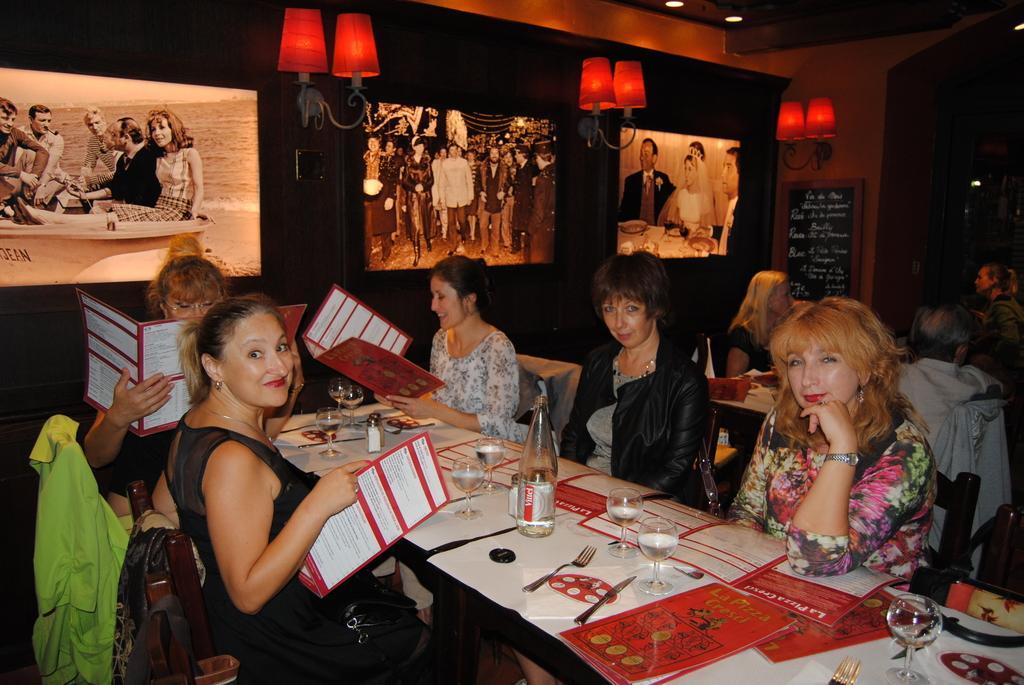Describe this image in one or two sentences. In this picture I can see 5 women sitting on chairs in front and I can see tables in front of them, on which there are glasses, a bottle, few papers and other things. I can also see that 3 women are holding cards in their hands. In the background I can see the wall on which there are 3 photos and I can see the lights. On the right side of this picture, I can see few more people and I can see a board on which there is something written. 